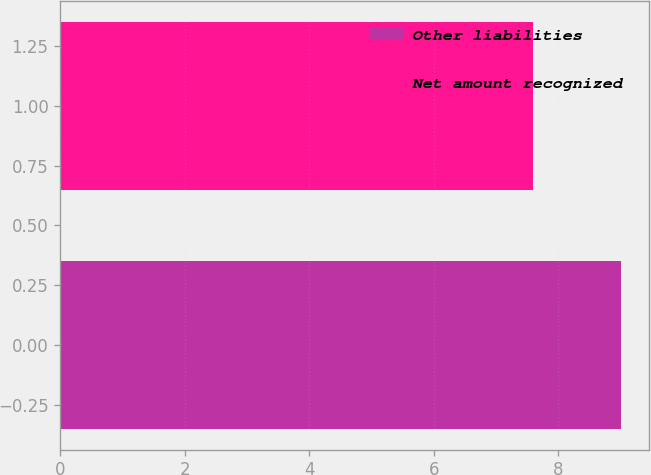Convert chart. <chart><loc_0><loc_0><loc_500><loc_500><bar_chart><fcel>Other liabilities<fcel>Net amount recognized<nl><fcel>9<fcel>7.6<nl></chart> 